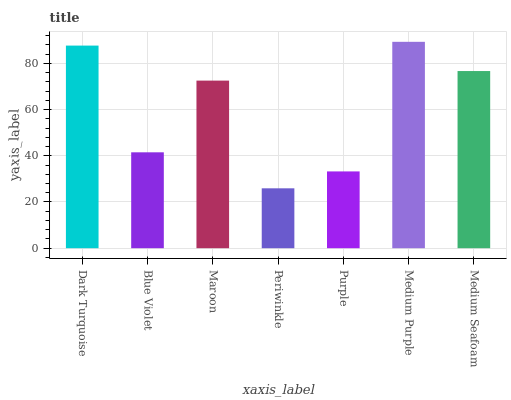Is Periwinkle the minimum?
Answer yes or no. Yes. Is Medium Purple the maximum?
Answer yes or no. Yes. Is Blue Violet the minimum?
Answer yes or no. No. Is Blue Violet the maximum?
Answer yes or no. No. Is Dark Turquoise greater than Blue Violet?
Answer yes or no. Yes. Is Blue Violet less than Dark Turquoise?
Answer yes or no. Yes. Is Blue Violet greater than Dark Turquoise?
Answer yes or no. No. Is Dark Turquoise less than Blue Violet?
Answer yes or no. No. Is Maroon the high median?
Answer yes or no. Yes. Is Maroon the low median?
Answer yes or no. Yes. Is Medium Purple the high median?
Answer yes or no. No. Is Medium Purple the low median?
Answer yes or no. No. 